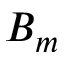Convert formula to latex. <formula><loc_0><loc_0><loc_500><loc_500>B _ { m }</formula> 